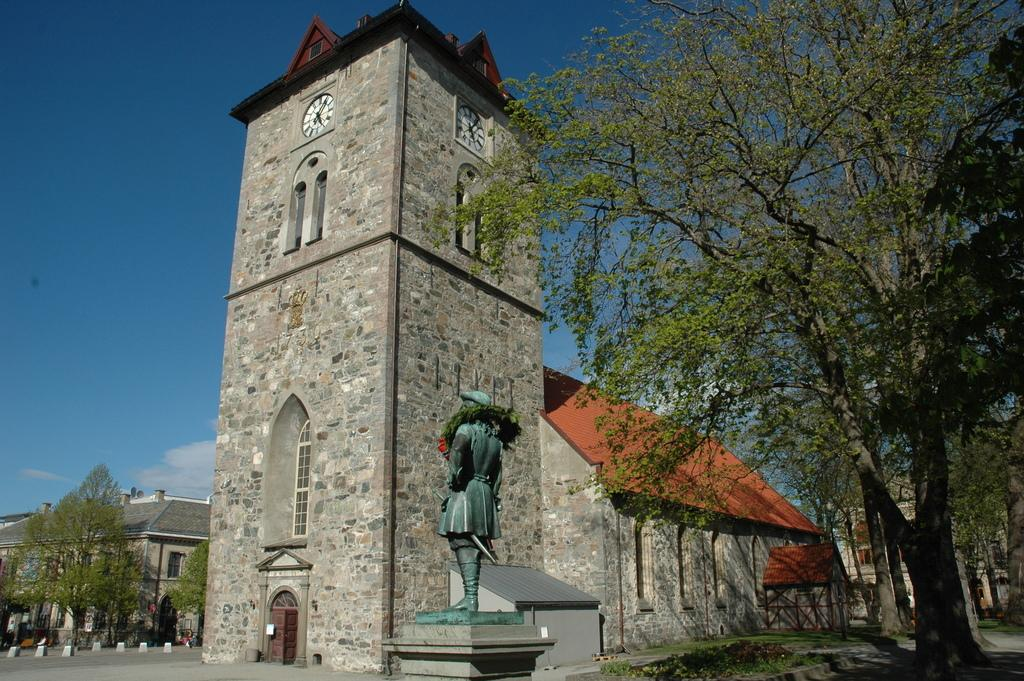What is the main structure visible in the image? There is a building in the image. What is located in front of the building? There is a statue in front of the building. What type of vegetation is present on either side of the statue? There are trees on either side of the statue. Can you tell me the name of the farmer who is holding the receipt in the image? There is no farmer or receipt present in the image. 